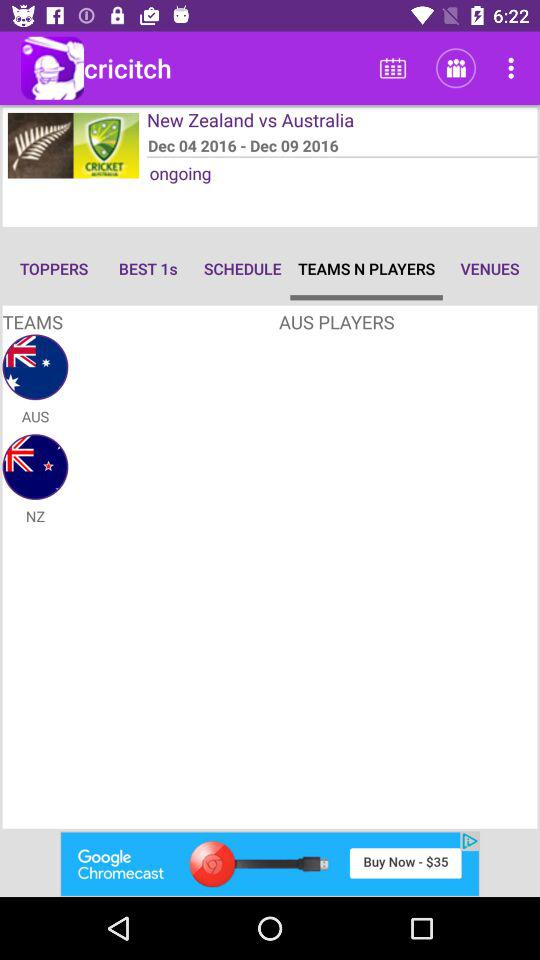On which tab of the application are we? The tab is "TEAMS N PLAYERS". 